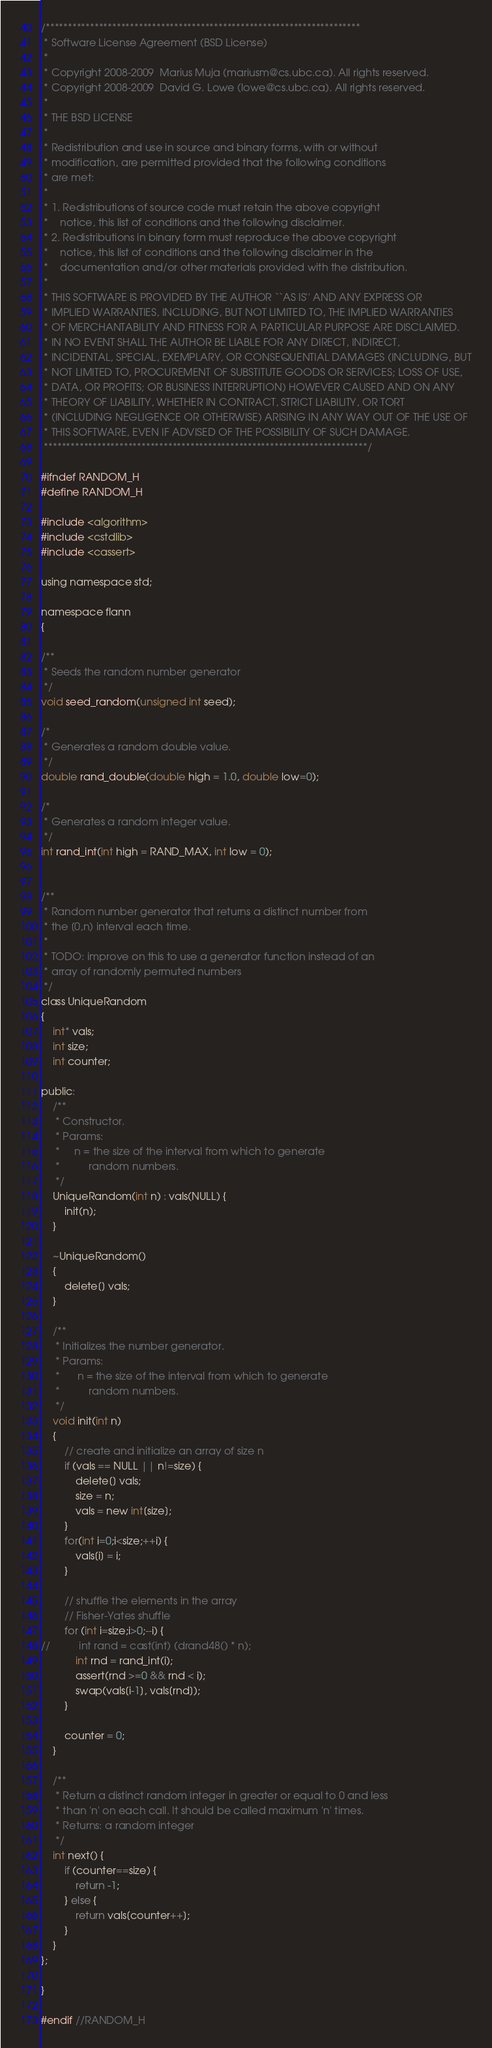Convert code to text. <code><loc_0><loc_0><loc_500><loc_500><_C_>/***********************************************************************
 * Software License Agreement (BSD License)
 *
 * Copyright 2008-2009  Marius Muja (mariusm@cs.ubc.ca). All rights reserved.
 * Copyright 2008-2009  David G. Lowe (lowe@cs.ubc.ca). All rights reserved.
 *
 * THE BSD LICENSE
 *
 * Redistribution and use in source and binary forms, with or without
 * modification, are permitted provided that the following conditions
 * are met:
 *
 * 1. Redistributions of source code must retain the above copyright
 *    notice, this list of conditions and the following disclaimer.
 * 2. Redistributions in binary form must reproduce the above copyright
 *    notice, this list of conditions and the following disclaimer in the
 *    documentation and/or other materials provided with the distribution.
 *
 * THIS SOFTWARE IS PROVIDED BY THE AUTHOR ``AS IS'' AND ANY EXPRESS OR
 * IMPLIED WARRANTIES, INCLUDING, BUT NOT LIMITED TO, THE IMPLIED WARRANTIES
 * OF MERCHANTABILITY AND FITNESS FOR A PARTICULAR PURPOSE ARE DISCLAIMED.
 * IN NO EVENT SHALL THE AUTHOR BE LIABLE FOR ANY DIRECT, INDIRECT,
 * INCIDENTAL, SPECIAL, EXEMPLARY, OR CONSEQUENTIAL DAMAGES (INCLUDING, BUT
 * NOT LIMITED TO, PROCUREMENT OF SUBSTITUTE GOODS OR SERVICES; LOSS OF USE,
 * DATA, OR PROFITS; OR BUSINESS INTERRUPTION) HOWEVER CAUSED AND ON ANY
 * THEORY OF LIABILITY, WHETHER IN CONTRACT, STRICT LIABILITY, OR TORT
 * (INCLUDING NEGLIGENCE OR OTHERWISE) ARISING IN ANY WAY OUT OF THE USE OF
 * THIS SOFTWARE, EVEN IF ADVISED OF THE POSSIBILITY OF SUCH DAMAGE.
 *************************************************************************/

#ifndef RANDOM_H
#define RANDOM_H

#include <algorithm>
#include <cstdlib>
#include <cassert>

using namespace std;

namespace flann
{

/**
 * Seeds the random number generator
 */
void seed_random(unsigned int seed);

/*
 * Generates a random double value.
 */
double rand_double(double high = 1.0, double low=0);

/*
 * Generates a random integer value.
 */
int rand_int(int high = RAND_MAX, int low = 0);


/**
 * Random number generator that returns a distinct number from
 * the [0,n) interval each time.
 *
 * TODO: improve on this to use a generator function instead of an
 * array of randomly permuted numbers
 */
class UniqueRandom
{
	int* vals;
    int size;
	int counter;

public:
	/**
	 * Constructor.
	 * Params:
	 *     n = the size of the interval from which to generate
	 *     		random numbers.
	 */
	UniqueRandom(int n) : vals(NULL) {
		init(n);
	}

	~UniqueRandom()
	{
		delete[] vals;
	}

	/**
	 * Initializes the number generator.
	 * Params:
	 * 		n = the size of the interval from which to generate
	 *     		random numbers.
	 */
	void init(int n)
	{
    	// create and initialize an array of size n
		if (vals == NULL || n!=size) {
            delete[] vals;
	        size = n;
            vals = new int[size];
    	}
    	for(int i=0;i<size;++i) {
			vals[i] = i;
		}

		// shuffle the elements in the array
        // Fisher-Yates shuffle
		for (int i=size;i>0;--i) {
// 			int rand = cast(int) (drand48() * n);
			int rnd = rand_int(i);
			assert(rnd >=0 && rnd < i);
			swap(vals[i-1], vals[rnd]);
		}

		counter = 0;
	}

	/**
	 * Return a distinct random integer in greater or equal to 0 and less
	 * than 'n' on each call. It should be called maximum 'n' times.
	 * Returns: a random integer
	 */
	int next() {
		if (counter==size) {
			return -1;
		} else {
			return vals[counter++];
		}
	}
};

}

#endif //RANDOM_H
</code> 